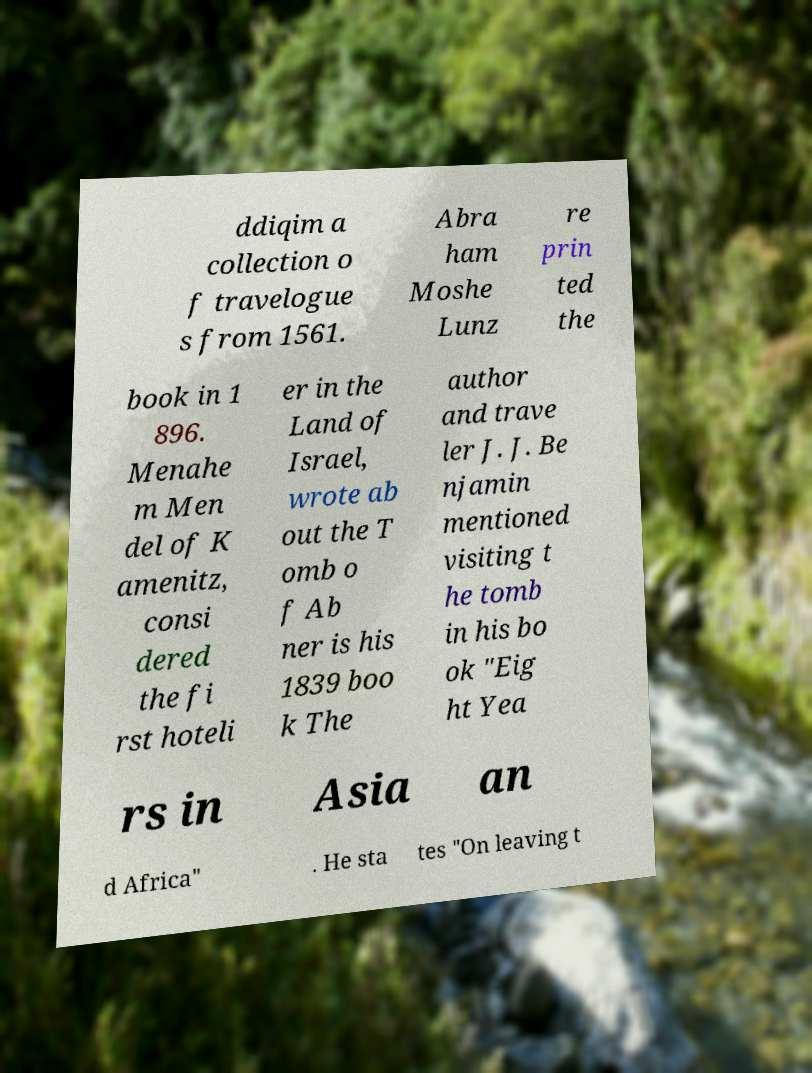Can you read and provide the text displayed in the image?This photo seems to have some interesting text. Can you extract and type it out for me? ddiqim a collection o f travelogue s from 1561. Abra ham Moshe Lunz re prin ted the book in 1 896. Menahe m Men del of K amenitz, consi dered the fi rst hoteli er in the Land of Israel, wrote ab out the T omb o f Ab ner is his 1839 boo k The author and trave ler J. J. Be njamin mentioned visiting t he tomb in his bo ok "Eig ht Yea rs in Asia an d Africa" . He sta tes "On leaving t 